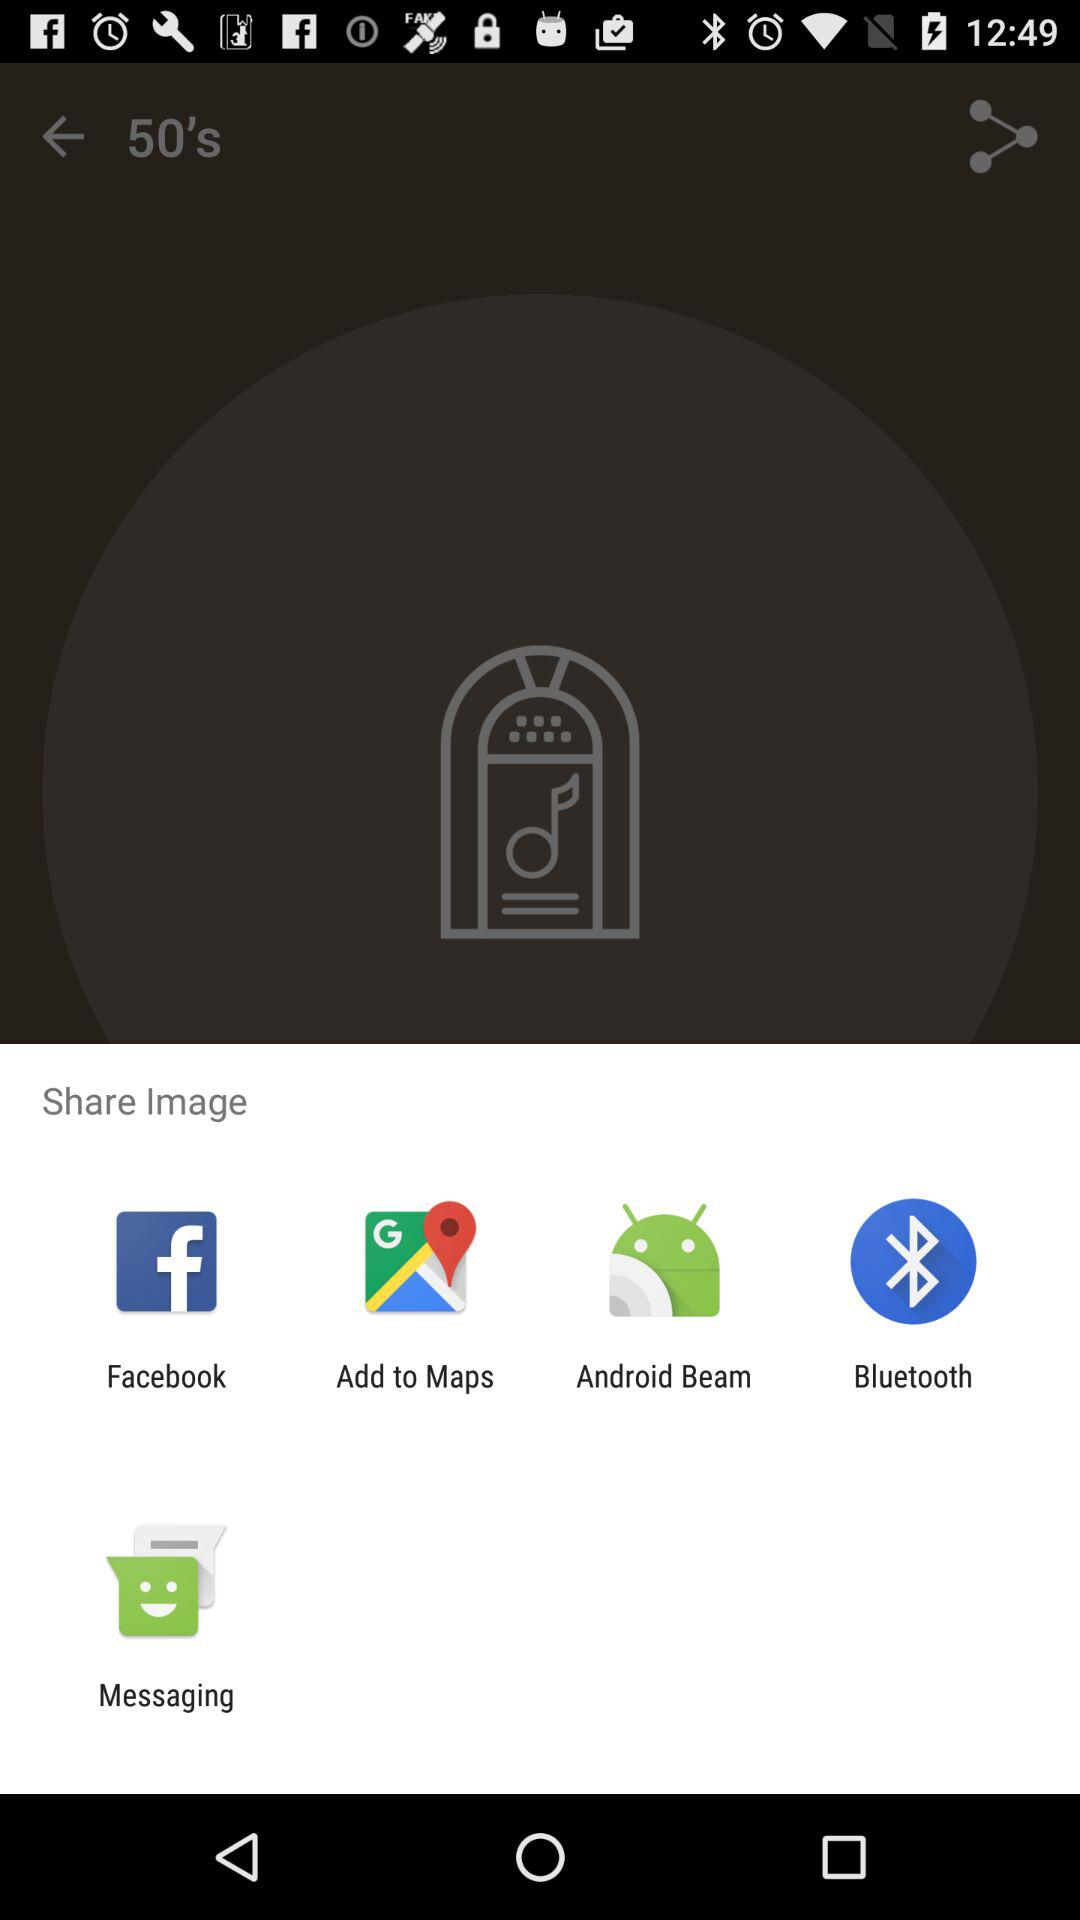Through which app can we share it? You can share it with "Facebook", "Add to Maps", "Android Beam", "Bluetooth" and "Messaging". 